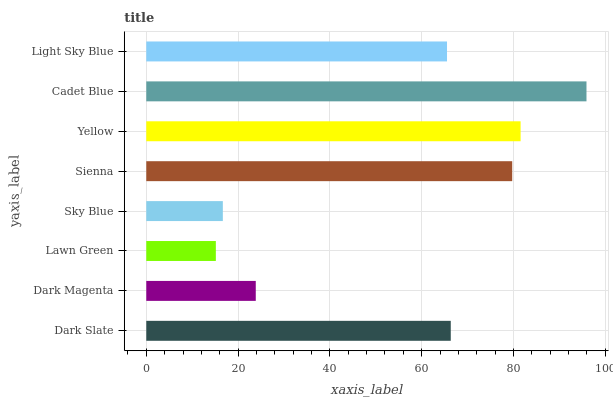Is Lawn Green the minimum?
Answer yes or no. Yes. Is Cadet Blue the maximum?
Answer yes or no. Yes. Is Dark Magenta the minimum?
Answer yes or no. No. Is Dark Magenta the maximum?
Answer yes or no. No. Is Dark Slate greater than Dark Magenta?
Answer yes or no. Yes. Is Dark Magenta less than Dark Slate?
Answer yes or no. Yes. Is Dark Magenta greater than Dark Slate?
Answer yes or no. No. Is Dark Slate less than Dark Magenta?
Answer yes or no. No. Is Dark Slate the high median?
Answer yes or no. Yes. Is Light Sky Blue the low median?
Answer yes or no. Yes. Is Dark Magenta the high median?
Answer yes or no. No. Is Dark Slate the low median?
Answer yes or no. No. 